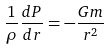Convert formula to latex. <formula><loc_0><loc_0><loc_500><loc_500>\frac { 1 } { \rho } \frac { d P } { d r } = - \frac { G m } { r ^ { 2 } }</formula> 